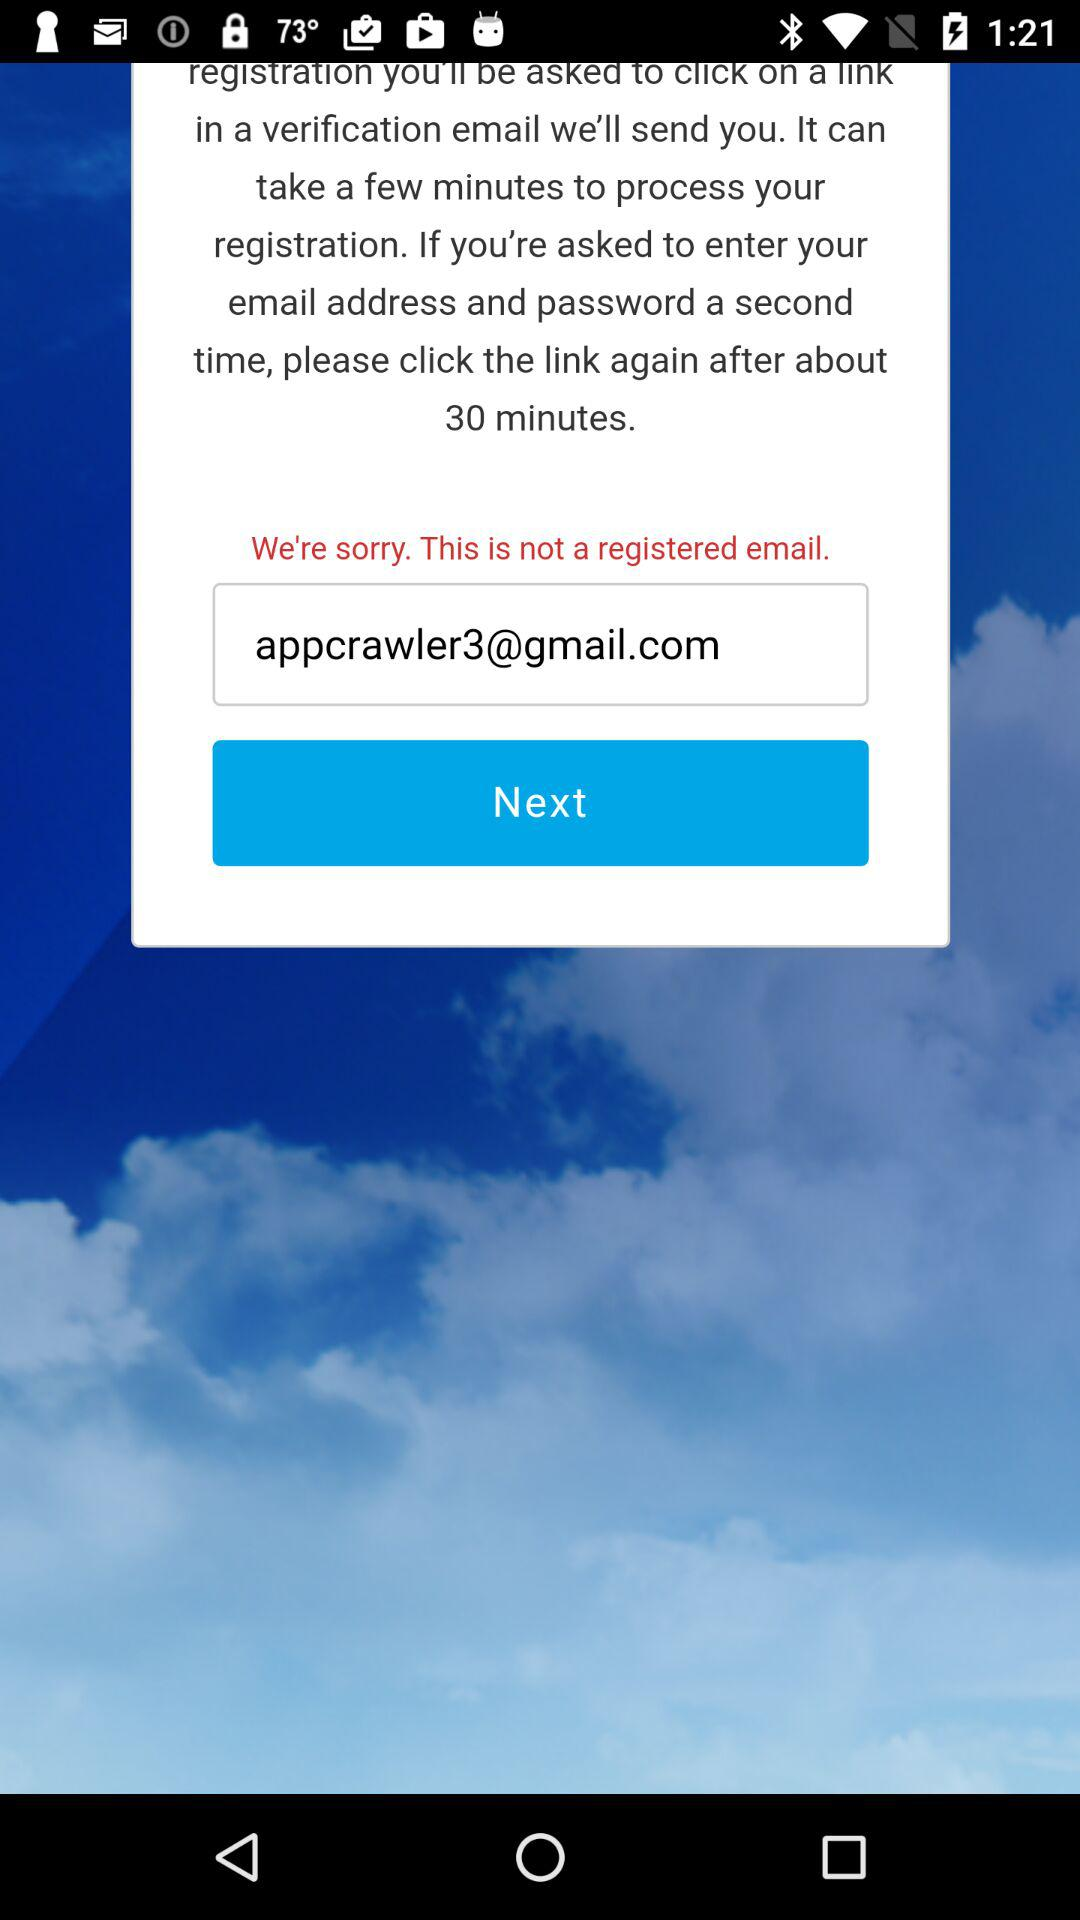After about how many minutes do we have to click the link again? We have to click the link again after about 30 minutes. 